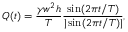<formula> <loc_0><loc_0><loc_500><loc_500>Q ( t ) = \frac { \gamma w ^ { 2 } h } { T } \frac { \sin ( 2 \pi t / T ) } { | \sin ( 2 \pi t / T ) | } ,</formula> 